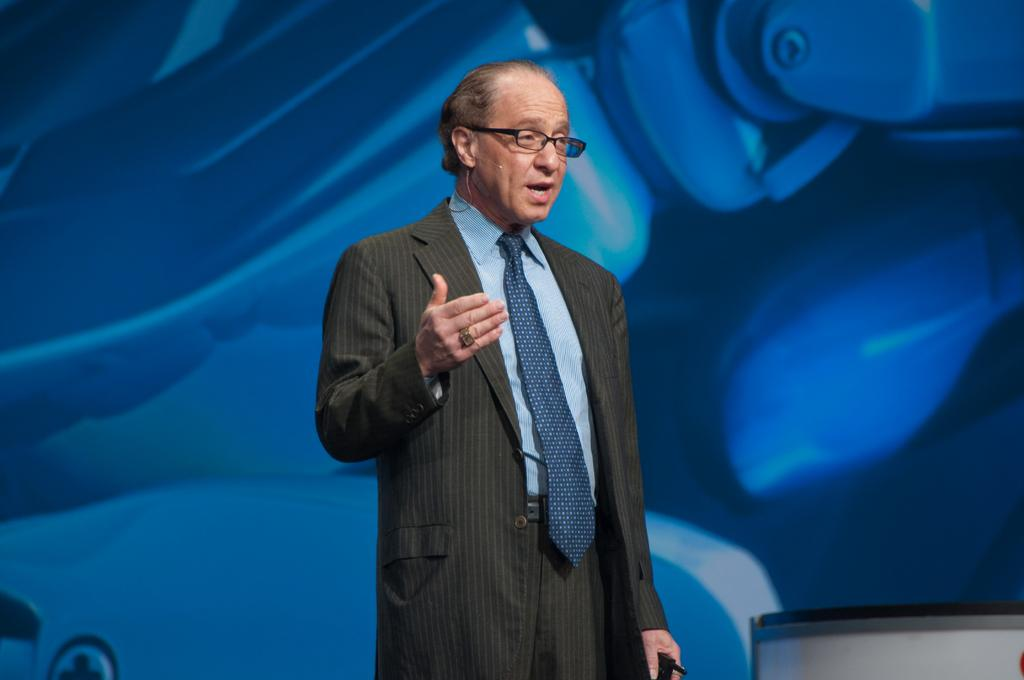What is the main subject of the image? There is a person standing in the image. What can be seen in the background of the image? There is a board in the background of the image. What is located in the bottom right corner of the image? There is an object in the bottom right corner of the image. How does the person in the image use their muscles to support the slip? There is no slip present in the image, and the person's muscles are not supporting anything. 